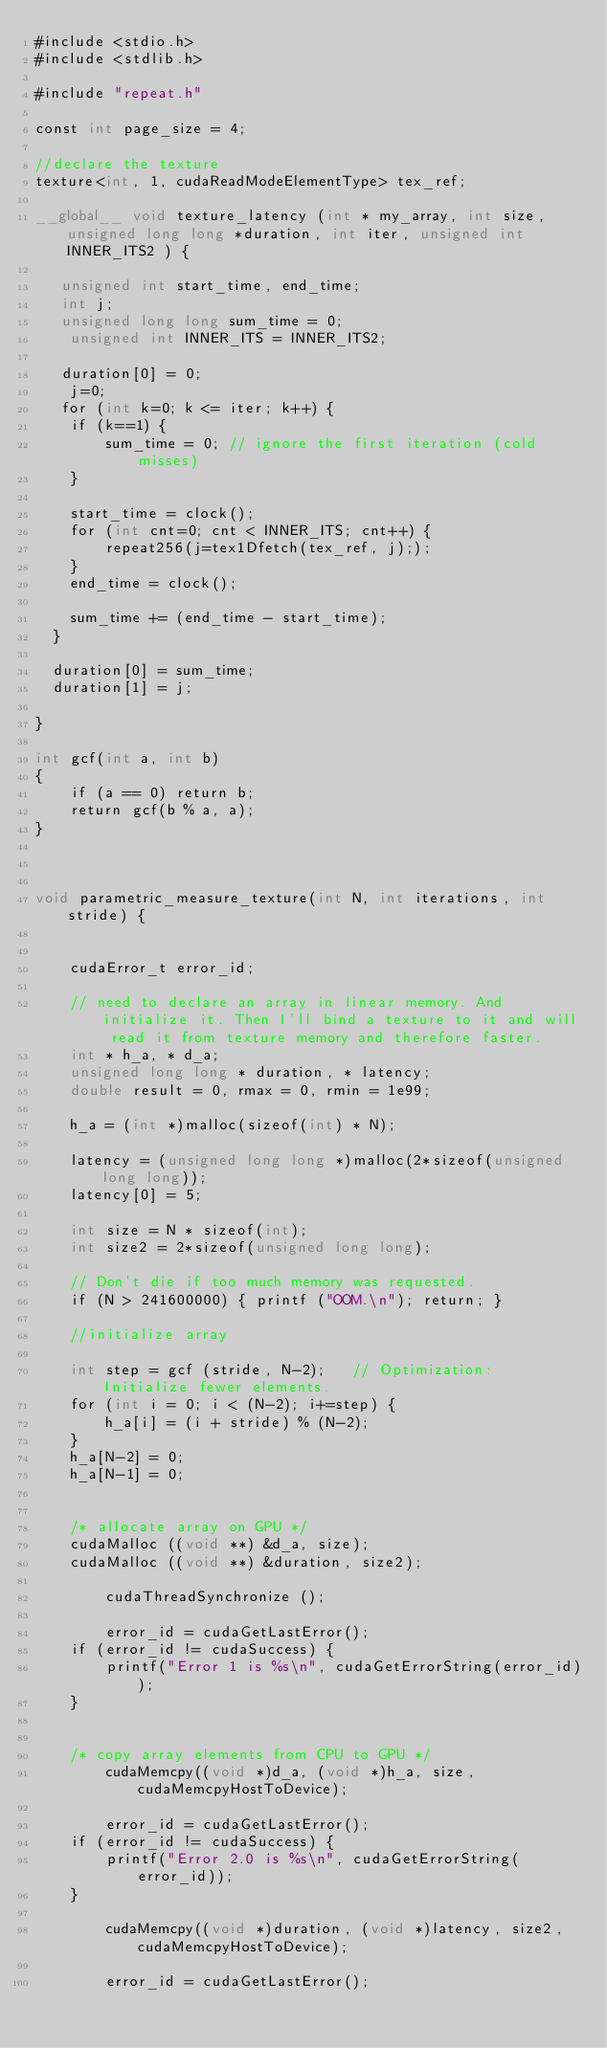Convert code to text. <code><loc_0><loc_0><loc_500><loc_500><_Cuda_>#include <stdio.h>
#include <stdlib.h>

#include "repeat.h"

const int page_size = 4;

//declare the texture
texture<int, 1, cudaReadModeElementType> tex_ref; 

__global__ void texture_latency (int * my_array, int size, unsigned long long *duration, int iter, unsigned int INNER_ITS2 ) {

   unsigned int start_time, end_time;
   int j;
   unsigned long long sum_time = 0;
	unsigned int INNER_ITS = INNER_ITS2;

   duration[0] = 0;
	j=0;
   for (int k=0; k <= iter; k++) {
  	if (k==1) {
		sum_time = 0; // ignore the first iteration (cold misses)
	}

	start_time = clock();
	for (int cnt=0; cnt < INNER_ITS; cnt++) {
   		repeat256(j=tex1Dfetch(tex_ref, j););
	}
   	end_time = clock();

	sum_time += (end_time - start_time);
  }

  duration[0] = sum_time;
  duration[1] = j;

}

int gcf(int a, int b)
{
	if (a == 0) return b;
	return gcf(b % a, a);
}



void parametric_measure_texture(int N, int iterations, int stride) {


	cudaError_t error_id;

	// need to declare an array in linear memory. And initialize it. Then I'll bind a texture to it and will read it from texture memory and therefore faster.
	int * h_a, * d_a;
	unsigned long long * duration, * latency;
	double result = 0, rmax = 0, rmin = 1e99;

	h_a = (int *)malloc(sizeof(int) * N);

	latency = (unsigned long long *)malloc(2*sizeof(unsigned long long));
	latency[0] = 5;

	int size = N * sizeof(int);
	int size2 = 2*sizeof(unsigned long long);

	// Don't die if too much memory was requested.
	if (N > 241600000) { printf ("OOM.\n"); return; }

	//initialize array
	
	int step = gcf (stride, N-2);	// Optimization: Initialize fewer elements.
	for (int i = 0; i < (N-2); i+=step) {
		h_a[i] = (i + stride) % (N-2);
	}
	h_a[N-2] = 0;
	h_a[N-1] = 0;


	/* allocate array on GPU */
	cudaMalloc ((void **) &d_a, size);
	cudaMalloc ((void **) &duration, size2);

        cudaThreadSynchronize ();

        error_id = cudaGetLastError();
	if (error_id != cudaSuccess) {
		printf("Error 1 is %s\n", cudaGetErrorString(error_id));
	}


	/* copy array elements from CPU to GPU */
        cudaMemcpy((void *)d_a, (void *)h_a, size, cudaMemcpyHostToDevice);

        error_id = cudaGetLastError();
	if (error_id != cudaSuccess) {
		printf("Error 2.0 is %s\n", cudaGetErrorString(error_id));
	}

        cudaMemcpy((void *)duration, (void *)latency, size2, cudaMemcpyHostToDevice);

        error_id = cudaGetLastError();</code> 